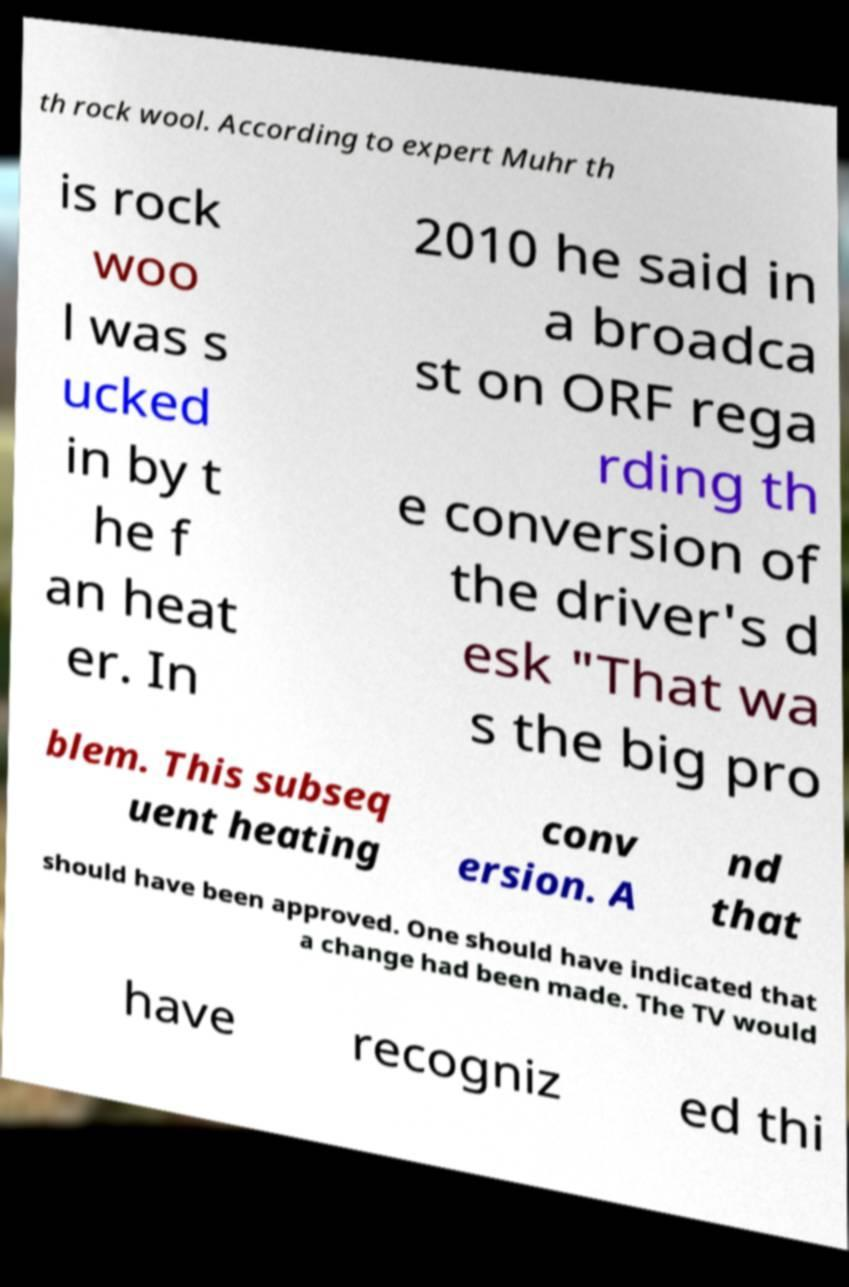Can you accurately transcribe the text from the provided image for me? th rock wool. According to expert Muhr th is rock woo l was s ucked in by t he f an heat er. In 2010 he said in a broadca st on ORF rega rding th e conversion of the driver's d esk "That wa s the big pro blem. This subseq uent heating conv ersion. A nd that should have been approved. One should have indicated that a change had been made. The TV would have recogniz ed thi 